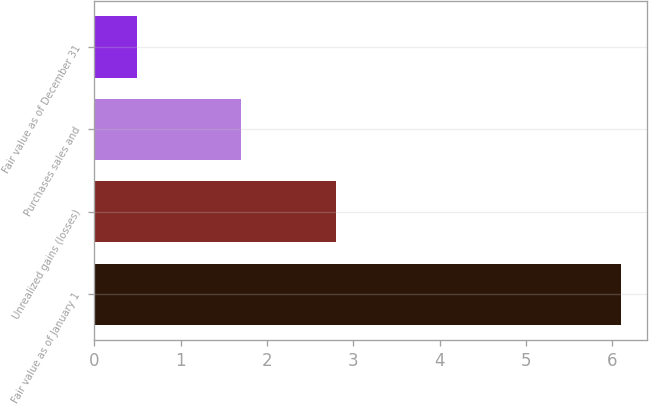<chart> <loc_0><loc_0><loc_500><loc_500><bar_chart><fcel>Fair value as of January 1<fcel>Unrealized gains (losses)<fcel>Purchases sales and<fcel>Fair value as of December 31<nl><fcel>6.1<fcel>2.8<fcel>1.7<fcel>0.5<nl></chart> 